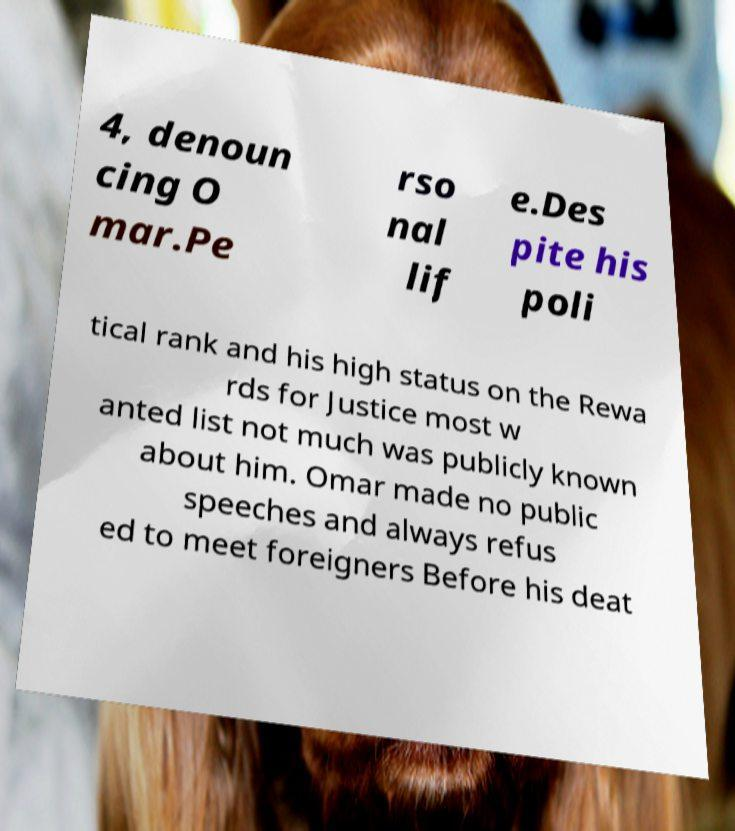I need the written content from this picture converted into text. Can you do that? 4, denoun cing O mar.Pe rso nal lif e.Des pite his poli tical rank and his high status on the Rewa rds for Justice most w anted list not much was publicly known about him. Omar made no public speeches and always refus ed to meet foreigners Before his deat 